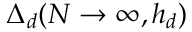<formula> <loc_0><loc_0><loc_500><loc_500>\Delta _ { d } ( N \rightarrow \infty , h _ { d } )</formula> 